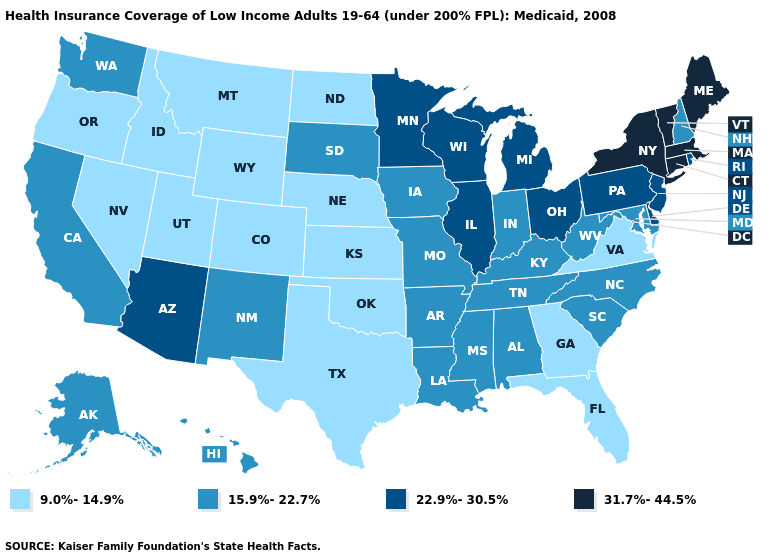Does the map have missing data?
Write a very short answer. No. What is the value of Tennessee?
Short answer required. 15.9%-22.7%. What is the value of Ohio?
Be succinct. 22.9%-30.5%. What is the value of New Jersey?
Be succinct. 22.9%-30.5%. What is the value of Wisconsin?
Keep it brief. 22.9%-30.5%. Does Nebraska have the lowest value in the MidWest?
Give a very brief answer. Yes. What is the lowest value in the South?
Short answer required. 9.0%-14.9%. Name the states that have a value in the range 31.7%-44.5%?
Be succinct. Connecticut, Maine, Massachusetts, New York, Vermont. Which states hav the highest value in the Northeast?
Concise answer only. Connecticut, Maine, Massachusetts, New York, Vermont. What is the value of Maryland?
Write a very short answer. 15.9%-22.7%. What is the value of Idaho?
Write a very short answer. 9.0%-14.9%. Name the states that have a value in the range 9.0%-14.9%?
Be succinct. Colorado, Florida, Georgia, Idaho, Kansas, Montana, Nebraska, Nevada, North Dakota, Oklahoma, Oregon, Texas, Utah, Virginia, Wyoming. Does Nevada have a lower value than Colorado?
Answer briefly. No. Among the states that border West Virginia , does Ohio have the highest value?
Concise answer only. Yes. Name the states that have a value in the range 9.0%-14.9%?
Give a very brief answer. Colorado, Florida, Georgia, Idaho, Kansas, Montana, Nebraska, Nevada, North Dakota, Oklahoma, Oregon, Texas, Utah, Virginia, Wyoming. 